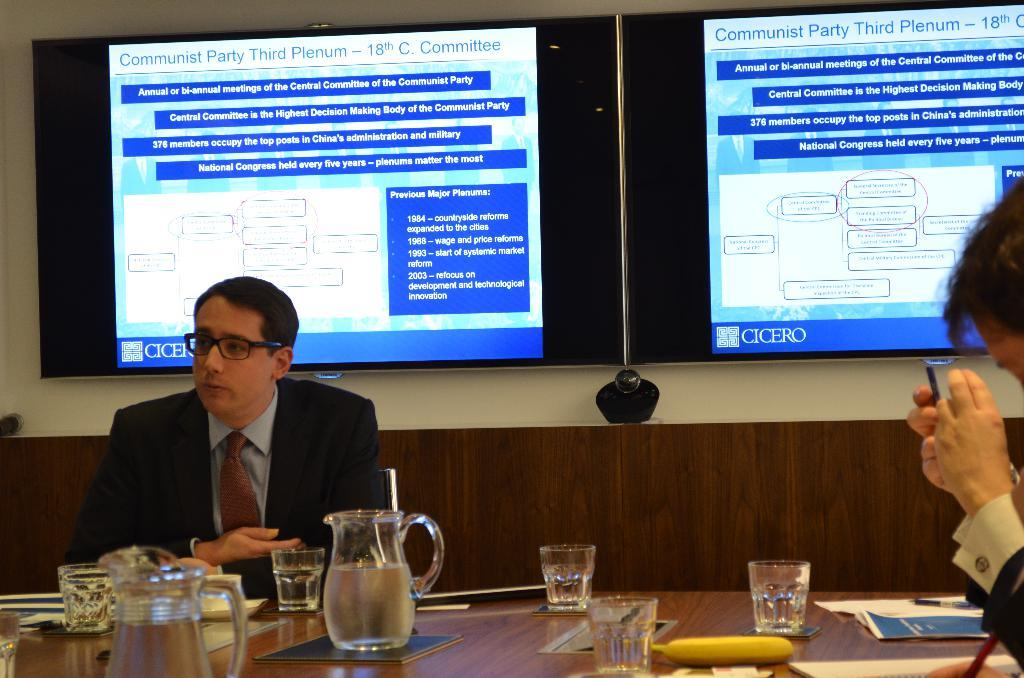<image>
Write a terse but informative summary of the picture. A man sits at a conference table while  a slideshow about the Communist Party is displayed behind him 